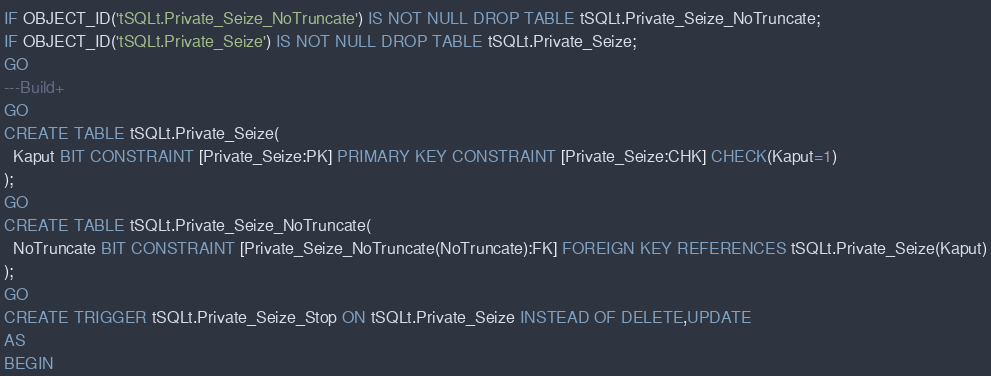Convert code to text. <code><loc_0><loc_0><loc_500><loc_500><_SQL_>IF OBJECT_ID('tSQLt.Private_Seize_NoTruncate') IS NOT NULL DROP TABLE tSQLt.Private_Seize_NoTruncate;
IF OBJECT_ID('tSQLt.Private_Seize') IS NOT NULL DROP TABLE tSQLt.Private_Seize;
GO
---Build+
GO
CREATE TABLE tSQLt.Private_Seize(
  Kaput BIT CONSTRAINT [Private_Seize:PK] PRIMARY KEY CONSTRAINT [Private_Seize:CHK] CHECK(Kaput=1)
);
GO
CREATE TABLE tSQLt.Private_Seize_NoTruncate(
  NoTruncate BIT CONSTRAINT [Private_Seize_NoTruncate(NoTruncate):FK] FOREIGN KEY REFERENCES tSQLt.Private_Seize(Kaput)
);
GO
CREATE TRIGGER tSQLt.Private_Seize_Stop ON tSQLt.Private_Seize INSTEAD OF DELETE,UPDATE
AS
BEGIN </code> 